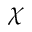<formula> <loc_0><loc_0><loc_500><loc_500>\chi</formula> 